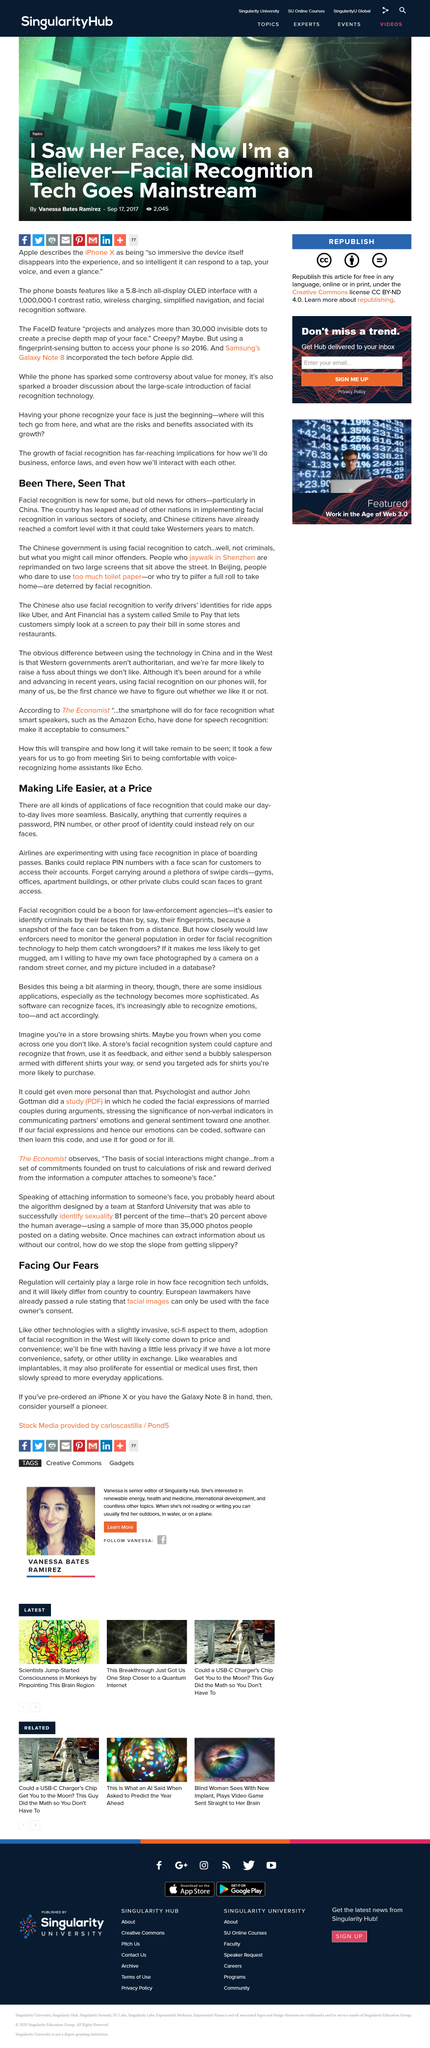Specify some key components in this picture. European lawmakers have declared that facial images can only be used with the explicit consent of the face owner. Face recognition technology can replace a PIN number for secure access to certain devices and applications. Yes, there are many applications of face recognition that can greatly enhance the seamlessness of lives. Facial recognition technology is being utilized in the city of Shenzhen, China to discourage jaywalkers from crossing the street in areas where it is prohibited. The title is written in the past tense. 